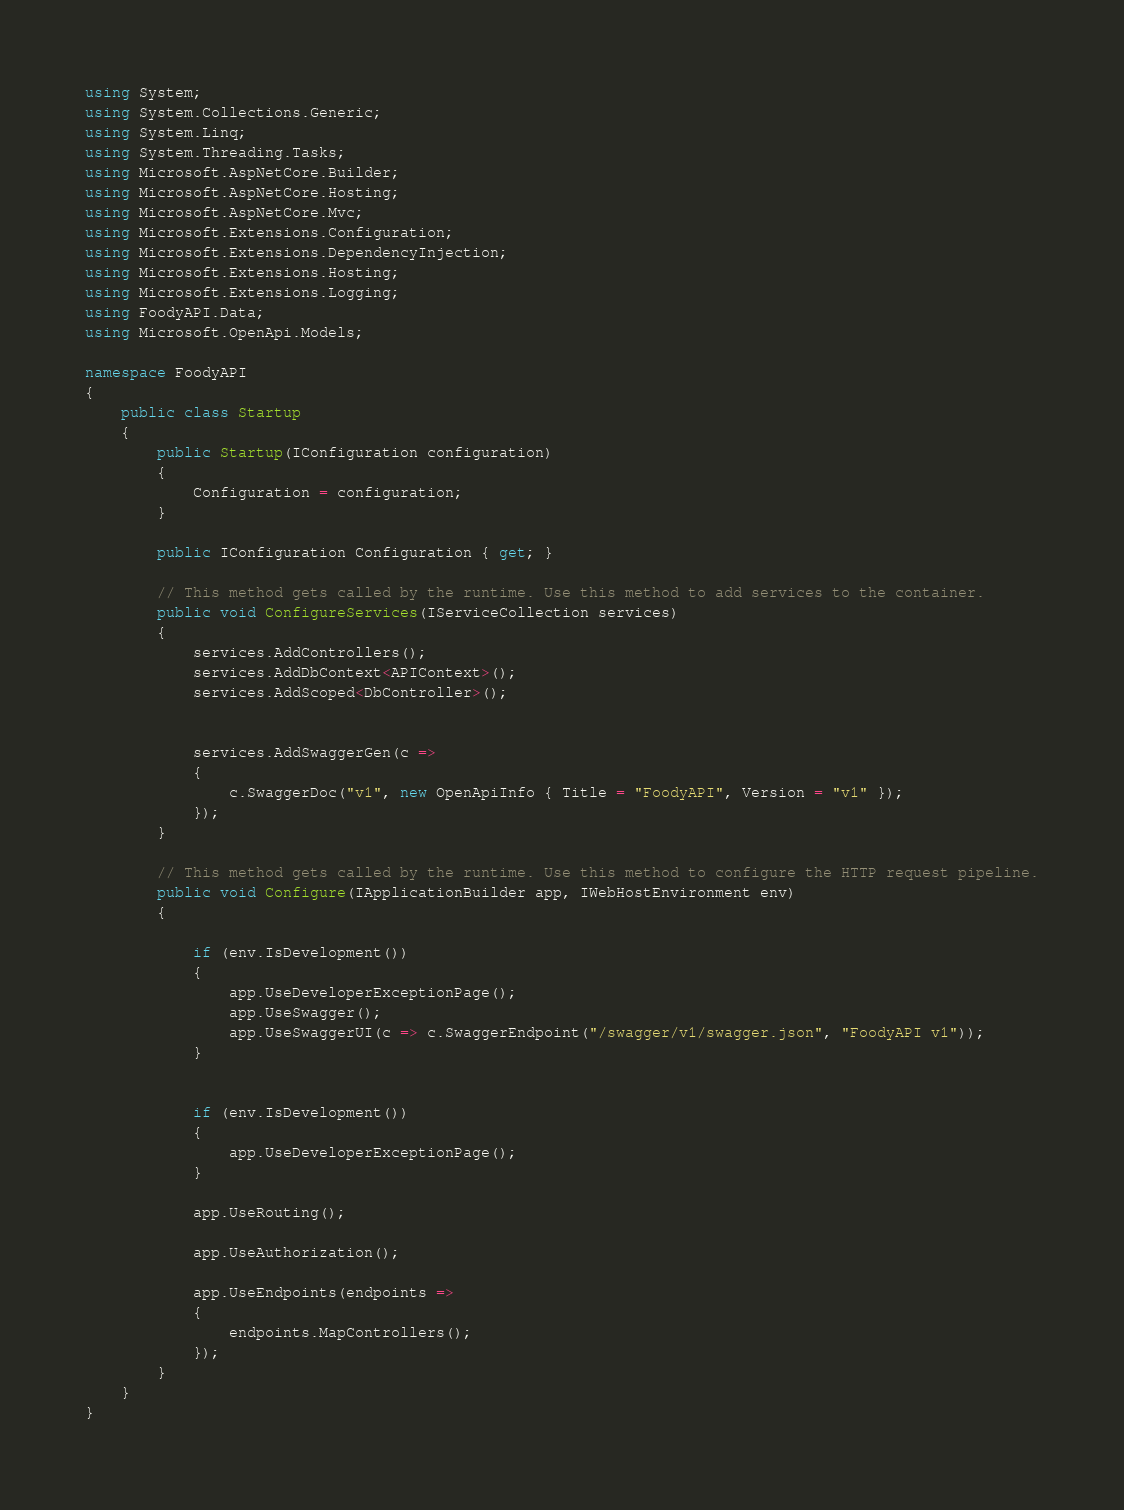Convert code to text. <code><loc_0><loc_0><loc_500><loc_500><_C#_>using System;
using System.Collections.Generic;
using System.Linq;
using System.Threading.Tasks;
using Microsoft.AspNetCore.Builder;
using Microsoft.AspNetCore.Hosting;
using Microsoft.AspNetCore.Mvc;
using Microsoft.Extensions.Configuration;
using Microsoft.Extensions.DependencyInjection;
using Microsoft.Extensions.Hosting;
using Microsoft.Extensions.Logging;
using FoodyAPI.Data;
using Microsoft.OpenApi.Models;

namespace FoodyAPI
{
    public class Startup
    {
        public Startup(IConfiguration configuration)
        {
            Configuration = configuration;
        }

        public IConfiguration Configuration { get; }

        // This method gets called by the runtime. Use this method to add services to the container.
        public void ConfigureServices(IServiceCollection services)
        {
            services.AddControllers();
            services.AddDbContext<APIContext>();
            services.AddScoped<DbController>();


            services.AddSwaggerGen(c =>
            {
                c.SwaggerDoc("v1", new OpenApiInfo { Title = "FoodyAPI", Version = "v1" });
            });
        }

        // This method gets called by the runtime. Use this method to configure the HTTP request pipeline.
        public void Configure(IApplicationBuilder app, IWebHostEnvironment env)
        {

            if (env.IsDevelopment())
            {
                app.UseDeveloperExceptionPage();
                app.UseSwagger();
                app.UseSwaggerUI(c => c.SwaggerEndpoint("/swagger/v1/swagger.json", "FoodyAPI v1"));
            }


            if (env.IsDevelopment())
            {
                app.UseDeveloperExceptionPage();
            }

            app.UseRouting();

            app.UseAuthorization();

            app.UseEndpoints(endpoints =>
            {
                endpoints.MapControllers();
            });
        }
    }
}
</code> 